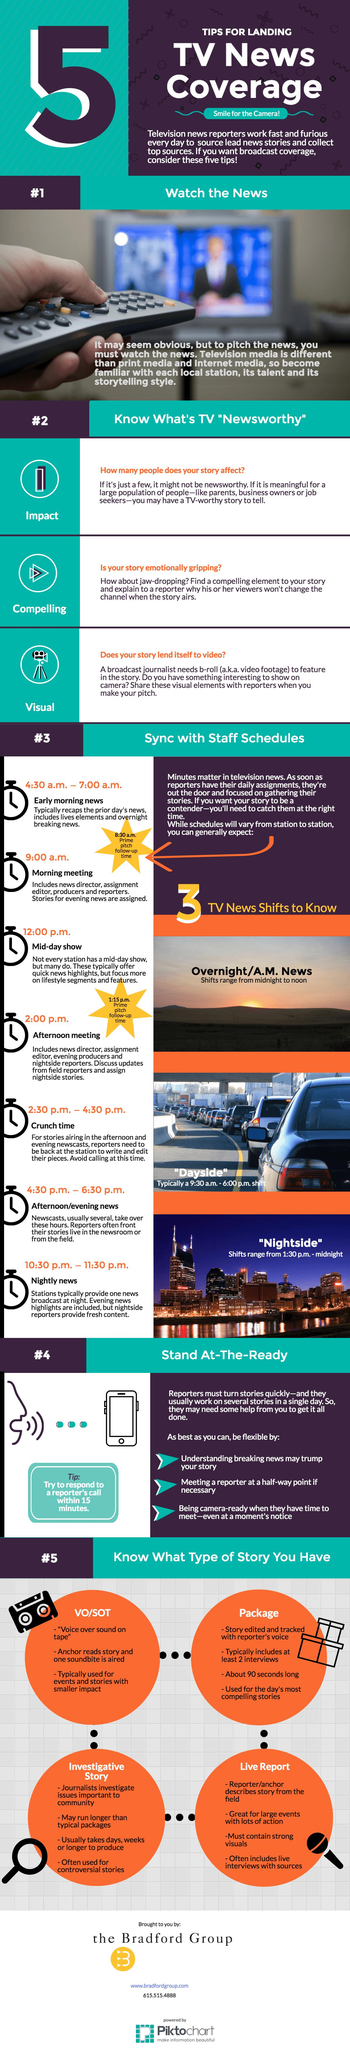Outline some significant characteristics in this image. There are three TV news shifts, namely overnight/A.M. News, Dayside, and Nightside. The follow-up times for prime pitch are scheduled at 8:30 am and 1:15 pm. 